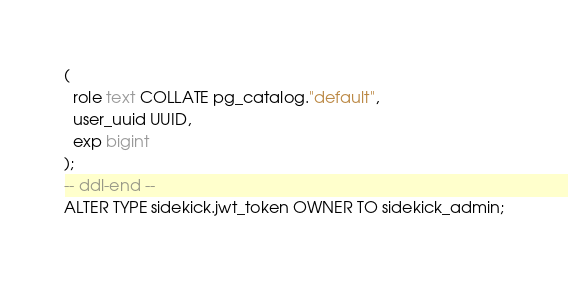Convert code to text. <code><loc_0><loc_0><loc_500><loc_500><_SQL_>(
  role text COLLATE pg_catalog."default",
  user_uuid UUID,
  exp bigint
);
-- ddl-end --
ALTER TYPE sidekick.jwt_token OWNER TO sidekick_admin;</code> 